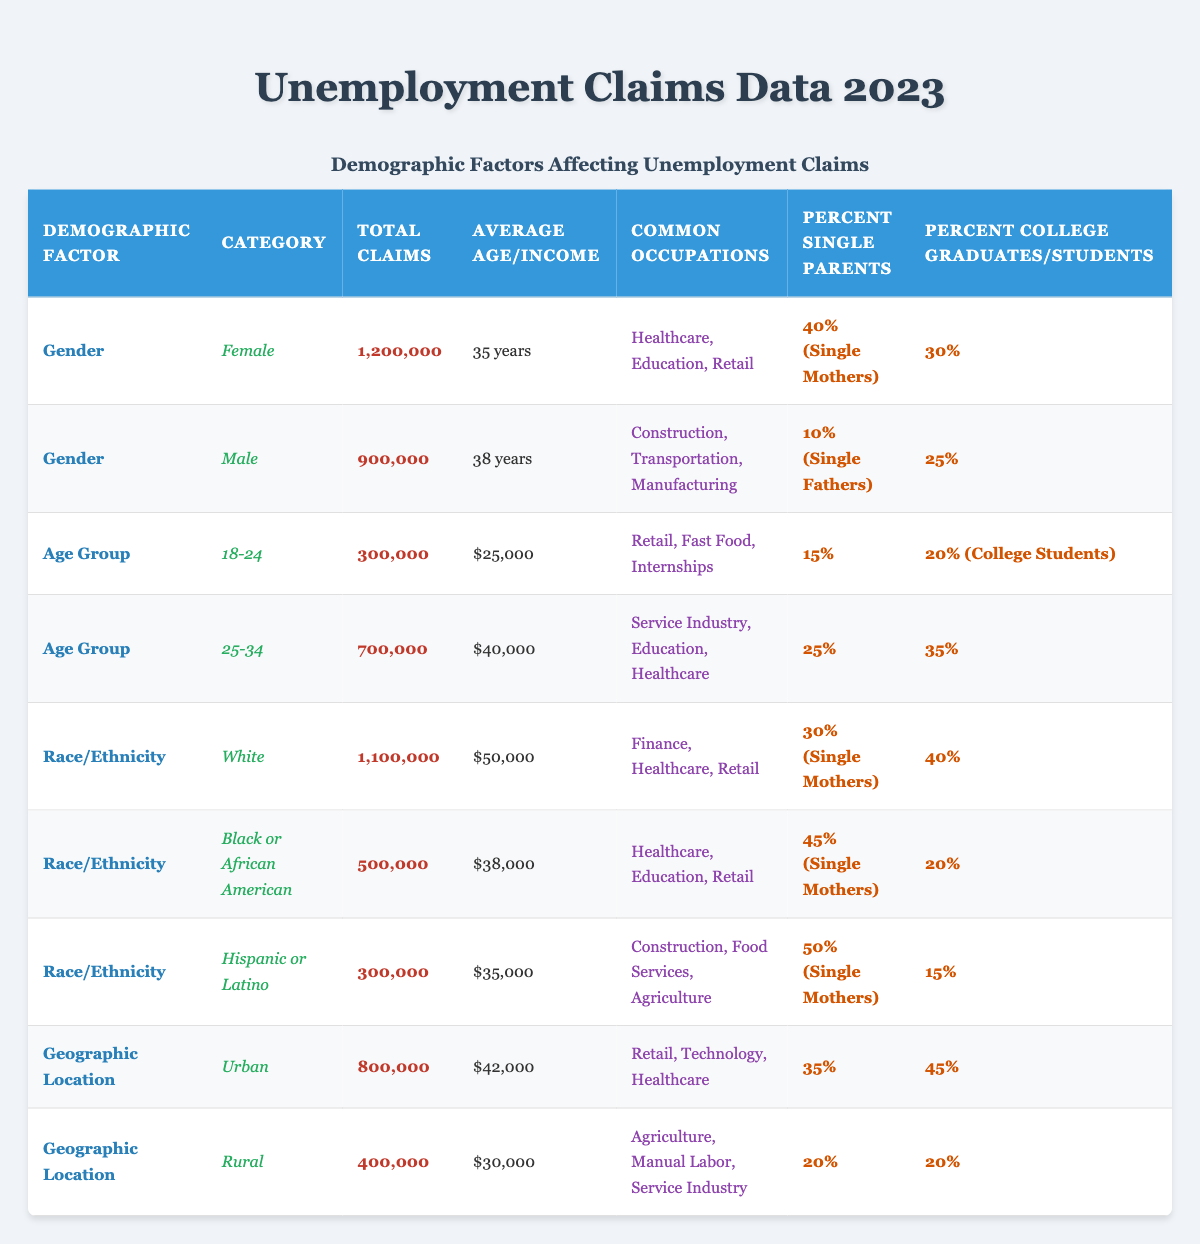What is the total number of unemployment claims by females in 2023? The total number of unemployment claims for females is directly provided in the table under the "Total Claims" column for the "Female" category in the "Gender" demographic factor, which is 1,200,000.
Answer: 1,200,000 What is the average income of individuals aged 25-34 who filed for unemployment? The average income for the age group of 25-34 is indicated in the table under the "Average Income" column, which is $40,000.
Answer: $40,000 Which demographic has the highest percentage of single mothers? By checking the "Percent Single Mothers" column across all demographic categories, the "Hispanic or Latino" category has the highest percentage at 50%.
Answer: Hispanic or Latino If we combine the total claims for the demographic groups "Urban" and "Rural", what is the sum? The total claims for "Urban" is 800,000 and for "Rural" is 400,000. Adding them together (800,000 + 400,000) gives a sum of 1,200,000.
Answer: 1,200,000 Is it true that the average age of unemployed males is higher than that of unemployed females? The average age of unemployed males is 38 years, and for unemployed females, it is 35 years. Since 38 is greater than 35, the statement is true.
Answer: Yes How much higher is the average income for the White demographic compared to the Hispanic or Latino demographic? The average income for the White demographic is $50,000, and for the Hispanic or Latino demographic, it is $35,000. To find the difference, subtract the Hispanic income from the White income: $50,000 - $35,000 = $15,000.
Answer: $15,000 What percentage of total claims from the "Black or African American" demographic are filed by single mothers? The percentage of single mothers within the "Black or African American" demographic is given in the table as 45%.
Answer: 45% Which age group has the least total claims and what is that number? The total claims for the age group 18-24 is 300,000, which is lower than the 700,000 for 25-34. Therefore, the age group 18-24 has the least total claims at 300,000.
Answer: 300,000 